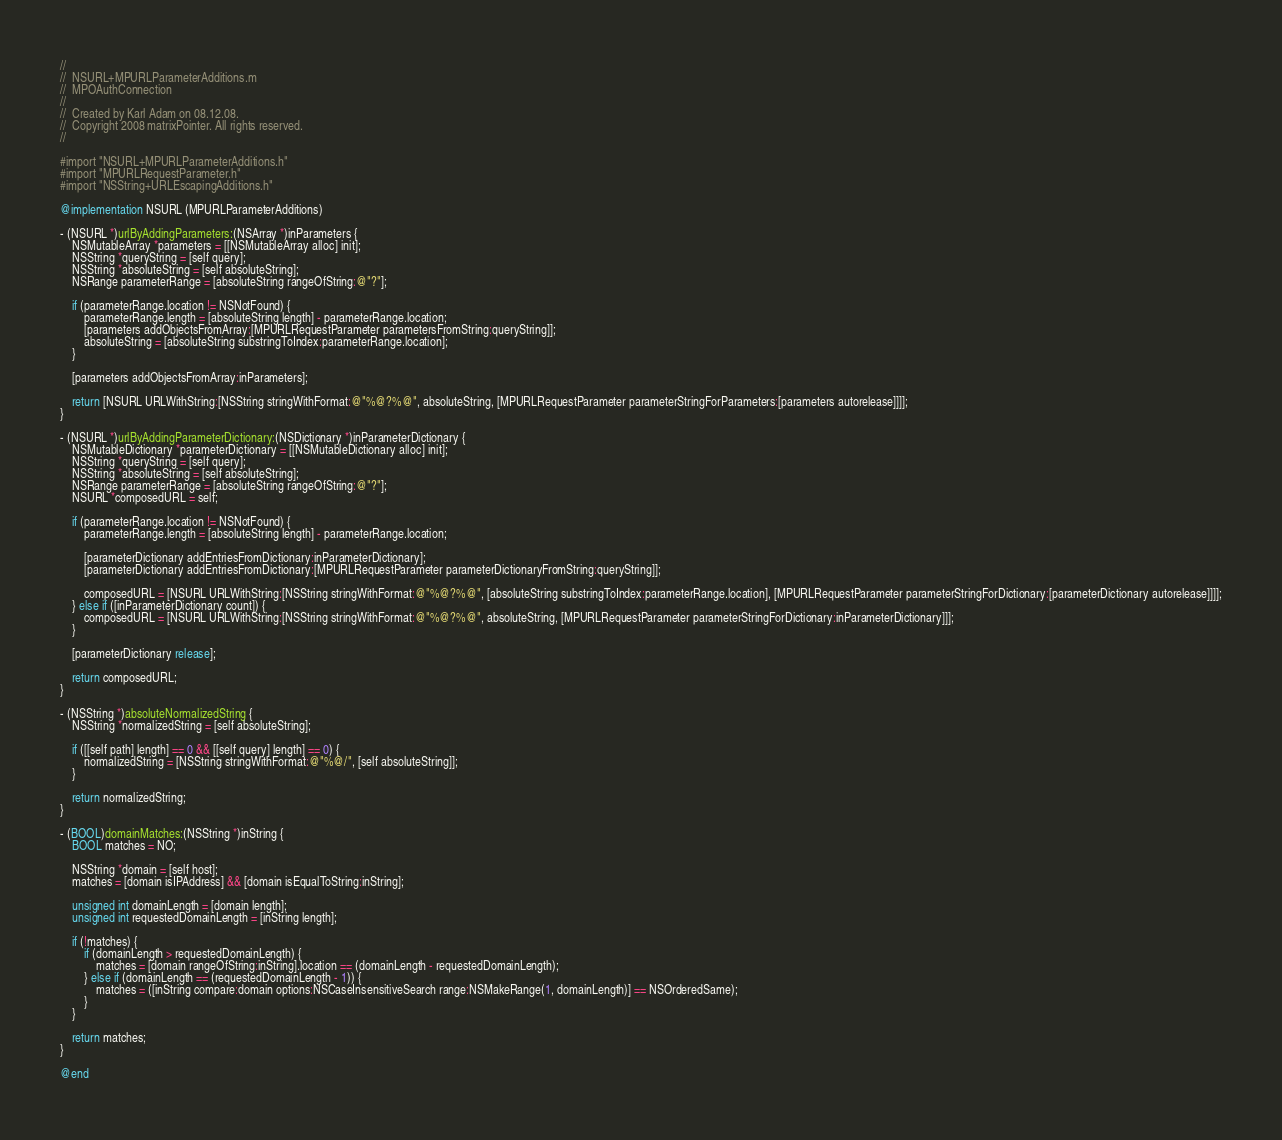<code> <loc_0><loc_0><loc_500><loc_500><_ObjectiveC_>//
//  NSURL+MPURLParameterAdditions.m
//  MPOAuthConnection
//
//  Created by Karl Adam on 08.12.08.
//  Copyright 2008 matrixPointer. All rights reserved.
//

#import "NSURL+MPURLParameterAdditions.h"
#import "MPURLRequestParameter.h"
#import "NSString+URLEscapingAdditions.h"

@implementation NSURL (MPURLParameterAdditions)

- (NSURL *)urlByAddingParameters:(NSArray *)inParameters {
	NSMutableArray *parameters = [[NSMutableArray alloc] init];
	NSString *queryString = [self query];
	NSString *absoluteString = [self absoluteString];
	NSRange parameterRange = [absoluteString rangeOfString:@"?"];
	
	if (parameterRange.location != NSNotFound) {
		parameterRange.length = [absoluteString length] - parameterRange.location;
		[parameters addObjectsFromArray:[MPURLRequestParameter parametersFromString:queryString]];
		absoluteString = [absoluteString substringToIndex:parameterRange.location];
	}
	
	[parameters addObjectsFromArray:inParameters];
	
	return [NSURL URLWithString:[NSString stringWithFormat:@"%@?%@", absoluteString, [MPURLRequestParameter parameterStringForParameters:[parameters autorelease]]]];
}

- (NSURL *)urlByAddingParameterDictionary:(NSDictionary *)inParameterDictionary {
	NSMutableDictionary *parameterDictionary = [[NSMutableDictionary alloc] init];
	NSString *queryString = [self query];
	NSString *absoluteString = [self absoluteString];
	NSRange parameterRange = [absoluteString rangeOfString:@"?"];
	NSURL *composedURL = self;
	
	if (parameterRange.location != NSNotFound) {
		parameterRange.length = [absoluteString length] - parameterRange.location;
		
		[parameterDictionary addEntriesFromDictionary:inParameterDictionary];
		[parameterDictionary addEntriesFromDictionary:[MPURLRequestParameter parameterDictionaryFromString:queryString]];
		
		composedURL = [NSURL URLWithString:[NSString stringWithFormat:@"%@?%@", [absoluteString substringToIndex:parameterRange.location], [MPURLRequestParameter parameterStringForDictionary:[parameterDictionary autorelease]]]];
	} else if ([inParameterDictionary count]) {
		composedURL = [NSURL URLWithString:[NSString stringWithFormat:@"%@?%@", absoluteString, [MPURLRequestParameter parameterStringForDictionary:inParameterDictionary]]];
	}
	
	[parameterDictionary release];

	return composedURL;
}

- (NSString *)absoluteNormalizedString {
	NSString *normalizedString = [self absoluteString];

	if ([[self path] length] == 0 && [[self query] length] == 0) {
		normalizedString = [NSString stringWithFormat:@"%@/", [self absoluteString]];
	}
	
	return normalizedString;
}

- (BOOL)domainMatches:(NSString *)inString {
	BOOL matches = NO;
	
	NSString *domain = [self host];
	matches = [domain isIPAddress] && [domain isEqualToString:inString];
	
	unsigned int domainLength = [domain length];
	unsigned int requestedDomainLength = [inString length];
	
	if (!matches) {
		if (domainLength > requestedDomainLength) {
			matches = [domain rangeOfString:inString].location == (domainLength - requestedDomainLength);
		} else if (domainLength == (requestedDomainLength - 1)) {
			matches = ([inString compare:domain options:NSCaseInsensitiveSearch range:NSMakeRange(1, domainLength)] == NSOrderedSame);
		}
	}
	
	return matches;
}

@end
</code> 